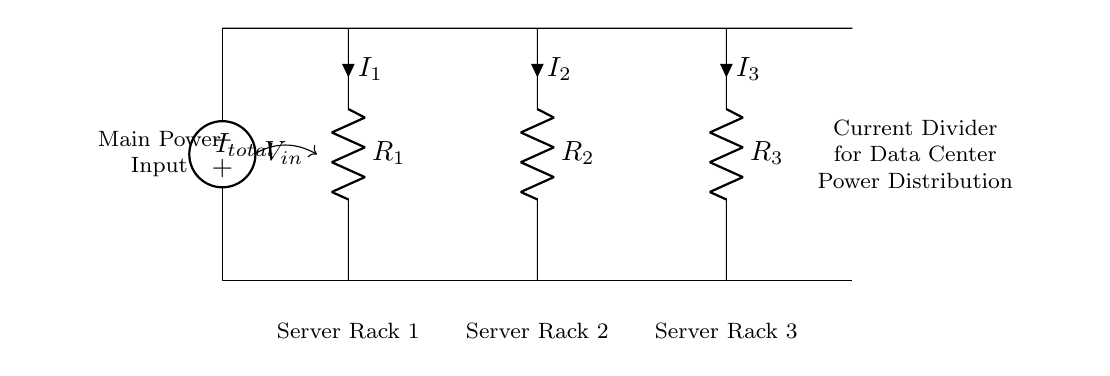What is the input voltage in this current divider circuit? The input voltage is labeled as V_in in the circuit diagram. It is the voltage supplied to the entire circuit from the main power input.
Answer: V_in How many resistors are present in the circuit? There are three resistors labeled as R_1, R_2, and R_3, which distribute the total current among different paths in the circuit.
Answer: Three What are the currents flowing through the resistors? The currents are labeled as I_1, I_2, and I_3, respectively, for R_1, R_2, and R_3. Each current value depends on the resistance and the total current entering through the input.
Answer: I_1, I_2, I_3 How does the total current split through the resistors in this circuit? In a current divider circuit, the total current splits inversely proportional to the resistance values of each parallel branch. Higher resistance results in lower current, while lower resistance results in higher current.
Answer: Inversely proportional Which rack receives the highest current if all resistors are of equal value? If all resistors are equal, the total current will split equally among them, leading to each rack receiving an equal portion of the total current.
Answer: Equal portion What is the purpose of this current divider circuit? The primary purpose of a current divider circuit is to effectively distribute the total current among multiple loads or circuits—in this case, for powering various server racks in a data center.
Answer: Power distribution 